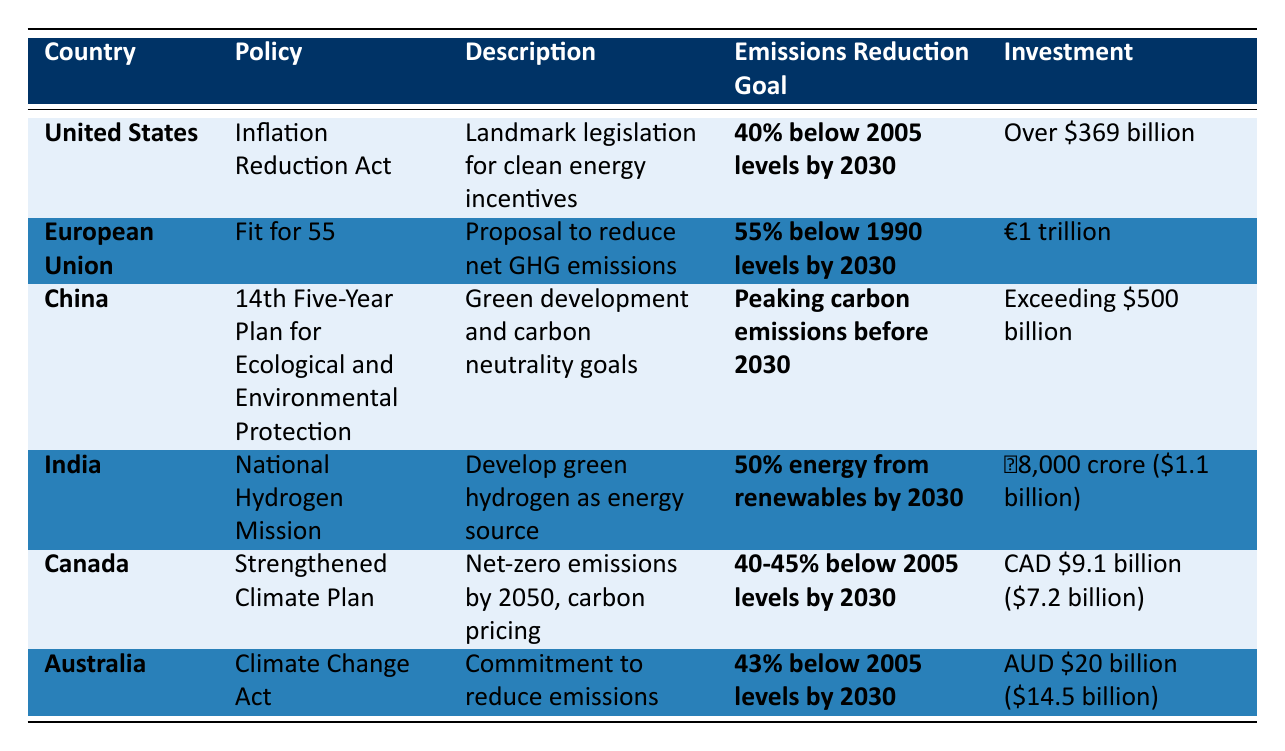What is the investment amount for the European Union's policy? According to the table, the investment amount for the European Union's "Fit for 55" policy is €1 trillion.
Answer: €1 trillion What is the emissions reduction goal for China? The table indicates that China's policy aims for peaking carbon emissions before 2030.
Answer: Peaking carbon emissions before 2030 Which country has the largest investment in environmental policy changes? By comparing the investment amounts listed, the United States with over $369 billion has the largest investment for its policy.
Answer: United States What is the difference in emissions reduction goals between the United States and Canada? The United States aims for a 40% reduction below 2005 levels by 2030, while Canada targets 40-45% below 2005 levels by 2030. The difference can vary between 0% to 5%.
Answer: 0% to 5% Is the investment for India's National Hydrogen Mission less than that of Australia? The investment for India's plan is ₹8,000 crore (approximately $1.1 billion), while Australia's investment is AUD $20 billion (approximately $14.5 billion), which is significantly more than India's.
Answer: Yes Which two countries have set their emissions reduction goals as a percentage below a specific year? The countries that have set emissions reduction goals as a percentage are the United States (40% below 2005 levels) and Canada (40-45% below 2005 levels).
Answer: United States and Canada How much investment has been allocated to Australia's Climate Change Act? The table states that Australia's investment amount for the Climate Change Act is AUD $20 billion (approximately $14.5 billion).
Answer: AUD $20 billion Which country's policy description emphasizes carbon neutrality by 2060? The policy description for China emphasizes carbon neutrality goals by 2060 as part of its "14th Five-Year Plan for Ecological and Environmental Protection."
Answer: China If the European Union achieves its emissions reduction goal, how much will it reduce emissions compared to 1990 levels? The European Union's goal is to reduce net greenhouse gas emissions by at least 55% by 2030 compared to 1990 levels, as stated in the table.
Answer: 55% below 1990 levels What is the combined total investment of Canada and Australia's environmental policies? The investment for Canada is CAD $9.1 billion (approximately $7.2 billion) and Australia's is AUD $20 billion (approximately $14.5 billion). To find the combined total, we need to sum these amounts: $7.2 billion + $14.5 billion = $21.7 billion.
Answer: $21.7 billion 